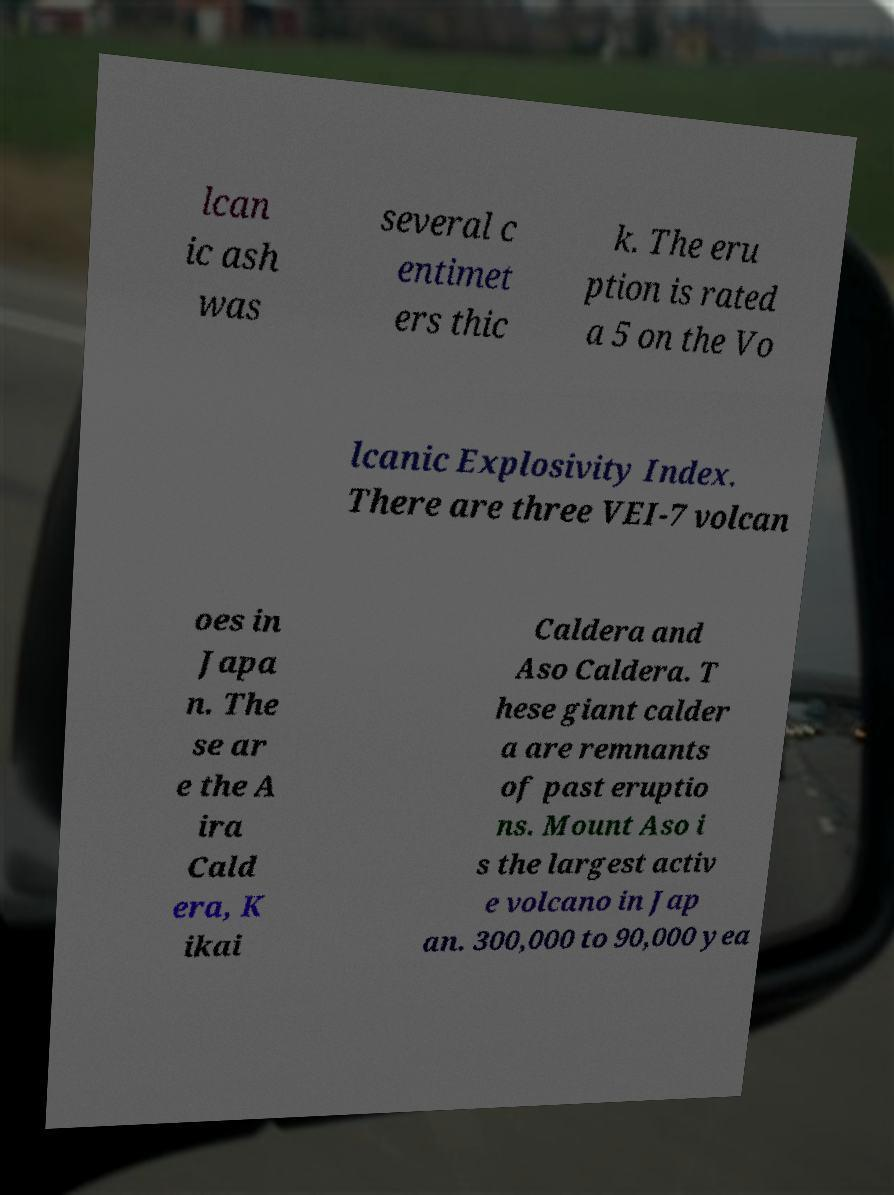For documentation purposes, I need the text within this image transcribed. Could you provide that? lcan ic ash was several c entimet ers thic k. The eru ption is rated a 5 on the Vo lcanic Explosivity Index. There are three VEI-7 volcan oes in Japa n. The se ar e the A ira Cald era, K ikai Caldera and Aso Caldera. T hese giant calder a are remnants of past eruptio ns. Mount Aso i s the largest activ e volcano in Jap an. 300,000 to 90,000 yea 